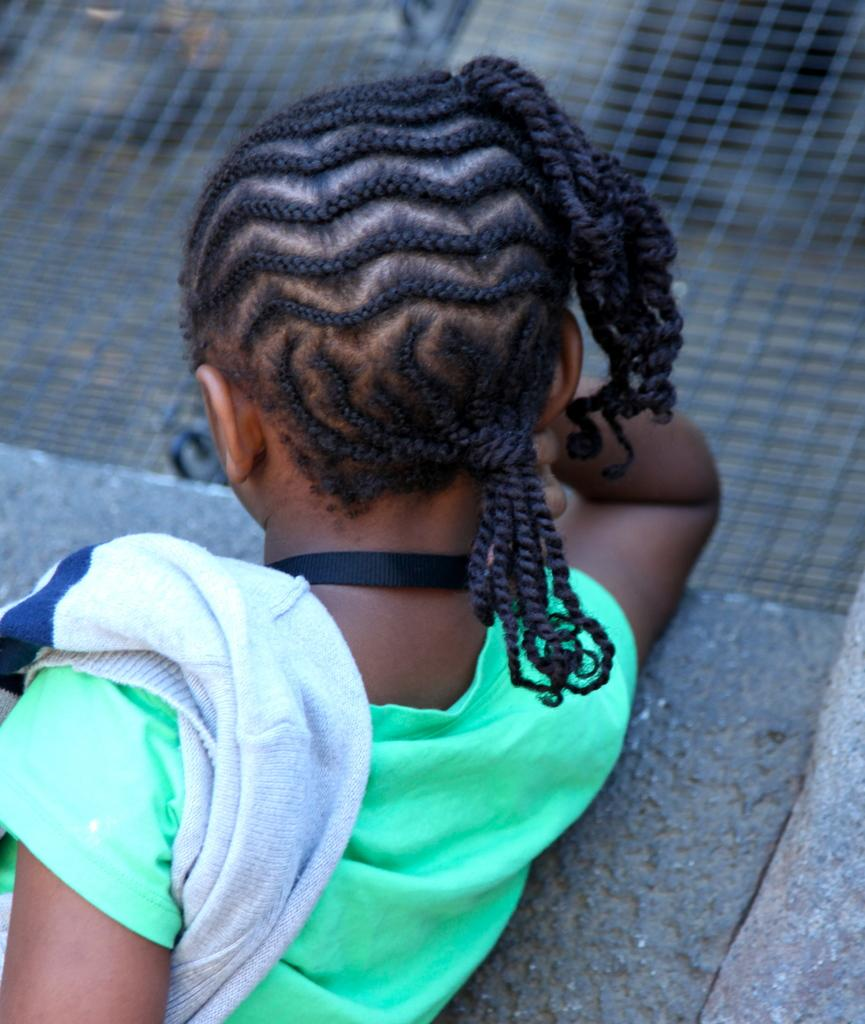What is the main subject of the image? There is a person in the image. What is the person wearing? The person is wearing a green t-shirt. Can you describe the background of the image? The background of the image is blurry. What can be seen through the blurry background? There is a mesh visible in the background. How many cows are visible in the image? There are no cows present in the image. What type of sweater is the person wearing in the image? The person is not wearing a sweater; they are wearing a green t-shirt. 